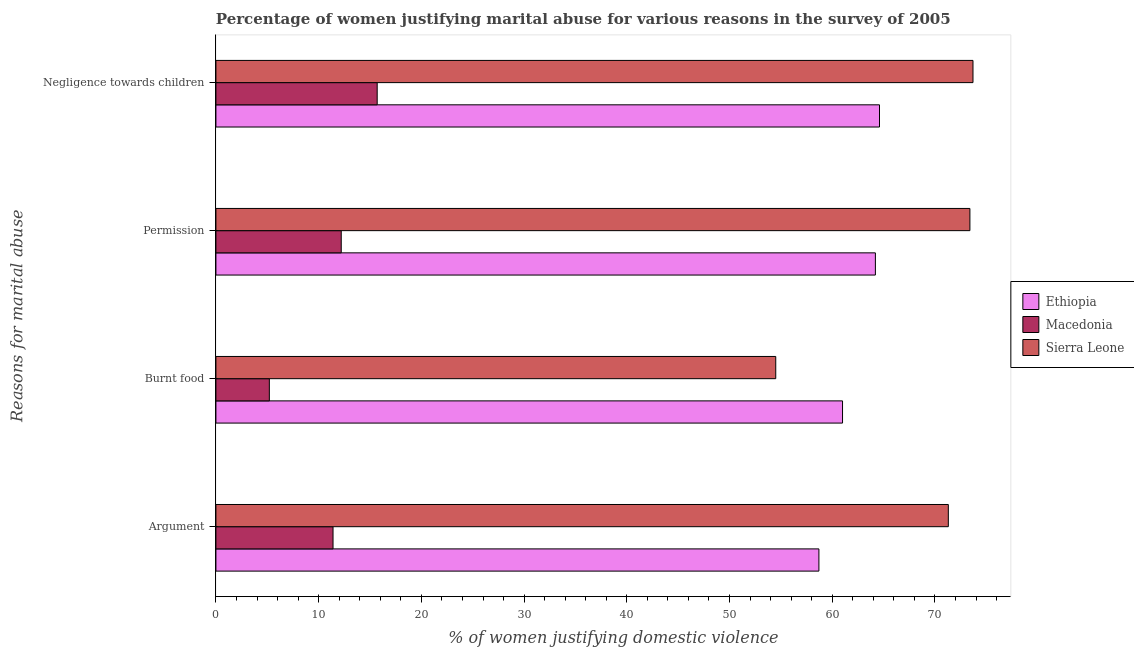How many different coloured bars are there?
Keep it short and to the point. 3. How many groups of bars are there?
Offer a very short reply. 4. Are the number of bars per tick equal to the number of legend labels?
Give a very brief answer. Yes. How many bars are there on the 4th tick from the bottom?
Provide a succinct answer. 3. What is the label of the 3rd group of bars from the top?
Your response must be concise. Burnt food. What is the percentage of women justifying abuse for showing negligence towards children in Sierra Leone?
Make the answer very short. 73.7. Across all countries, what is the maximum percentage of women justifying abuse for going without permission?
Offer a very short reply. 73.4. In which country was the percentage of women justifying abuse for going without permission maximum?
Keep it short and to the point. Sierra Leone. In which country was the percentage of women justifying abuse for going without permission minimum?
Offer a terse response. Macedonia. What is the total percentage of women justifying abuse for going without permission in the graph?
Provide a short and direct response. 149.8. What is the difference between the percentage of women justifying abuse in the case of an argument in Sierra Leone and that in Ethiopia?
Your response must be concise. 12.6. What is the difference between the percentage of women justifying abuse in the case of an argument in Macedonia and the percentage of women justifying abuse for going without permission in Ethiopia?
Your response must be concise. -52.8. What is the average percentage of women justifying abuse for going without permission per country?
Keep it short and to the point. 49.93. What is the difference between the percentage of women justifying abuse for showing negligence towards children and percentage of women justifying abuse for going without permission in Sierra Leone?
Your answer should be very brief. 0.3. What is the ratio of the percentage of women justifying abuse for showing negligence towards children in Macedonia to that in Ethiopia?
Your answer should be very brief. 0.24. Is the percentage of women justifying abuse for showing negligence towards children in Sierra Leone less than that in Macedonia?
Offer a terse response. No. Is the difference between the percentage of women justifying abuse for going without permission in Ethiopia and Macedonia greater than the difference between the percentage of women justifying abuse in the case of an argument in Ethiopia and Macedonia?
Keep it short and to the point. Yes. What is the difference between the highest and the second highest percentage of women justifying abuse in the case of an argument?
Ensure brevity in your answer.  12.6. What is the difference between the highest and the lowest percentage of women justifying abuse for showing negligence towards children?
Your answer should be compact. 58. Is the sum of the percentage of women justifying abuse for going without permission in Ethiopia and Macedonia greater than the maximum percentage of women justifying abuse in the case of an argument across all countries?
Your answer should be very brief. Yes. What does the 3rd bar from the top in Burnt food represents?
Give a very brief answer. Ethiopia. What does the 1st bar from the bottom in Argument represents?
Your answer should be very brief. Ethiopia. Is it the case that in every country, the sum of the percentage of women justifying abuse in the case of an argument and percentage of women justifying abuse for burning food is greater than the percentage of women justifying abuse for going without permission?
Offer a very short reply. Yes. Does the graph contain any zero values?
Provide a short and direct response. No. How many legend labels are there?
Provide a succinct answer. 3. How are the legend labels stacked?
Make the answer very short. Vertical. What is the title of the graph?
Your answer should be compact. Percentage of women justifying marital abuse for various reasons in the survey of 2005. What is the label or title of the X-axis?
Ensure brevity in your answer.  % of women justifying domestic violence. What is the label or title of the Y-axis?
Your response must be concise. Reasons for marital abuse. What is the % of women justifying domestic violence in Ethiopia in Argument?
Your answer should be compact. 58.7. What is the % of women justifying domestic violence in Macedonia in Argument?
Keep it short and to the point. 11.4. What is the % of women justifying domestic violence of Sierra Leone in Argument?
Your answer should be very brief. 71.3. What is the % of women justifying domestic violence of Sierra Leone in Burnt food?
Ensure brevity in your answer.  54.5. What is the % of women justifying domestic violence in Ethiopia in Permission?
Your answer should be very brief. 64.2. What is the % of women justifying domestic violence of Sierra Leone in Permission?
Your answer should be very brief. 73.4. What is the % of women justifying domestic violence in Ethiopia in Negligence towards children?
Ensure brevity in your answer.  64.6. What is the % of women justifying domestic violence of Sierra Leone in Negligence towards children?
Ensure brevity in your answer.  73.7. Across all Reasons for marital abuse, what is the maximum % of women justifying domestic violence of Ethiopia?
Give a very brief answer. 64.6. Across all Reasons for marital abuse, what is the maximum % of women justifying domestic violence of Macedonia?
Offer a very short reply. 15.7. Across all Reasons for marital abuse, what is the maximum % of women justifying domestic violence of Sierra Leone?
Make the answer very short. 73.7. Across all Reasons for marital abuse, what is the minimum % of women justifying domestic violence in Ethiopia?
Make the answer very short. 58.7. Across all Reasons for marital abuse, what is the minimum % of women justifying domestic violence of Sierra Leone?
Your answer should be compact. 54.5. What is the total % of women justifying domestic violence of Ethiopia in the graph?
Keep it short and to the point. 248.5. What is the total % of women justifying domestic violence in Macedonia in the graph?
Make the answer very short. 44.5. What is the total % of women justifying domestic violence of Sierra Leone in the graph?
Your answer should be very brief. 272.9. What is the difference between the % of women justifying domestic violence of Macedonia in Argument and that in Burnt food?
Offer a terse response. 6.2. What is the difference between the % of women justifying domestic violence in Sierra Leone in Argument and that in Negligence towards children?
Make the answer very short. -2.4. What is the difference between the % of women justifying domestic violence in Ethiopia in Burnt food and that in Permission?
Offer a very short reply. -3.2. What is the difference between the % of women justifying domestic violence of Macedonia in Burnt food and that in Permission?
Provide a succinct answer. -7. What is the difference between the % of women justifying domestic violence in Sierra Leone in Burnt food and that in Permission?
Ensure brevity in your answer.  -18.9. What is the difference between the % of women justifying domestic violence in Ethiopia in Burnt food and that in Negligence towards children?
Offer a terse response. -3.6. What is the difference between the % of women justifying domestic violence in Sierra Leone in Burnt food and that in Negligence towards children?
Offer a terse response. -19.2. What is the difference between the % of women justifying domestic violence of Ethiopia in Argument and the % of women justifying domestic violence of Macedonia in Burnt food?
Provide a succinct answer. 53.5. What is the difference between the % of women justifying domestic violence in Ethiopia in Argument and the % of women justifying domestic violence in Sierra Leone in Burnt food?
Ensure brevity in your answer.  4.2. What is the difference between the % of women justifying domestic violence of Macedonia in Argument and the % of women justifying domestic violence of Sierra Leone in Burnt food?
Ensure brevity in your answer.  -43.1. What is the difference between the % of women justifying domestic violence in Ethiopia in Argument and the % of women justifying domestic violence in Macedonia in Permission?
Provide a short and direct response. 46.5. What is the difference between the % of women justifying domestic violence of Ethiopia in Argument and the % of women justifying domestic violence of Sierra Leone in Permission?
Offer a terse response. -14.7. What is the difference between the % of women justifying domestic violence in Macedonia in Argument and the % of women justifying domestic violence in Sierra Leone in Permission?
Your answer should be very brief. -62. What is the difference between the % of women justifying domestic violence of Ethiopia in Argument and the % of women justifying domestic violence of Sierra Leone in Negligence towards children?
Make the answer very short. -15. What is the difference between the % of women justifying domestic violence in Macedonia in Argument and the % of women justifying domestic violence in Sierra Leone in Negligence towards children?
Your response must be concise. -62.3. What is the difference between the % of women justifying domestic violence of Ethiopia in Burnt food and the % of women justifying domestic violence of Macedonia in Permission?
Offer a terse response. 48.8. What is the difference between the % of women justifying domestic violence of Ethiopia in Burnt food and the % of women justifying domestic violence of Sierra Leone in Permission?
Offer a very short reply. -12.4. What is the difference between the % of women justifying domestic violence of Macedonia in Burnt food and the % of women justifying domestic violence of Sierra Leone in Permission?
Your answer should be very brief. -68.2. What is the difference between the % of women justifying domestic violence of Ethiopia in Burnt food and the % of women justifying domestic violence of Macedonia in Negligence towards children?
Your response must be concise. 45.3. What is the difference between the % of women justifying domestic violence of Ethiopia in Burnt food and the % of women justifying domestic violence of Sierra Leone in Negligence towards children?
Your response must be concise. -12.7. What is the difference between the % of women justifying domestic violence in Macedonia in Burnt food and the % of women justifying domestic violence in Sierra Leone in Negligence towards children?
Provide a succinct answer. -68.5. What is the difference between the % of women justifying domestic violence in Ethiopia in Permission and the % of women justifying domestic violence in Macedonia in Negligence towards children?
Your response must be concise. 48.5. What is the difference between the % of women justifying domestic violence in Macedonia in Permission and the % of women justifying domestic violence in Sierra Leone in Negligence towards children?
Provide a succinct answer. -61.5. What is the average % of women justifying domestic violence of Ethiopia per Reasons for marital abuse?
Your answer should be very brief. 62.12. What is the average % of women justifying domestic violence of Macedonia per Reasons for marital abuse?
Make the answer very short. 11.12. What is the average % of women justifying domestic violence of Sierra Leone per Reasons for marital abuse?
Provide a succinct answer. 68.22. What is the difference between the % of women justifying domestic violence of Ethiopia and % of women justifying domestic violence of Macedonia in Argument?
Offer a very short reply. 47.3. What is the difference between the % of women justifying domestic violence of Ethiopia and % of women justifying domestic violence of Sierra Leone in Argument?
Keep it short and to the point. -12.6. What is the difference between the % of women justifying domestic violence in Macedonia and % of women justifying domestic violence in Sierra Leone in Argument?
Your answer should be very brief. -59.9. What is the difference between the % of women justifying domestic violence of Ethiopia and % of women justifying domestic violence of Macedonia in Burnt food?
Your answer should be very brief. 55.8. What is the difference between the % of women justifying domestic violence in Ethiopia and % of women justifying domestic violence in Sierra Leone in Burnt food?
Provide a short and direct response. 6.5. What is the difference between the % of women justifying domestic violence in Macedonia and % of women justifying domestic violence in Sierra Leone in Burnt food?
Offer a terse response. -49.3. What is the difference between the % of women justifying domestic violence in Ethiopia and % of women justifying domestic violence in Sierra Leone in Permission?
Your answer should be very brief. -9.2. What is the difference between the % of women justifying domestic violence in Macedonia and % of women justifying domestic violence in Sierra Leone in Permission?
Your answer should be very brief. -61.2. What is the difference between the % of women justifying domestic violence in Ethiopia and % of women justifying domestic violence in Macedonia in Negligence towards children?
Give a very brief answer. 48.9. What is the difference between the % of women justifying domestic violence in Macedonia and % of women justifying domestic violence in Sierra Leone in Negligence towards children?
Your answer should be very brief. -58. What is the ratio of the % of women justifying domestic violence of Ethiopia in Argument to that in Burnt food?
Provide a short and direct response. 0.96. What is the ratio of the % of women justifying domestic violence in Macedonia in Argument to that in Burnt food?
Make the answer very short. 2.19. What is the ratio of the % of women justifying domestic violence of Sierra Leone in Argument to that in Burnt food?
Your answer should be compact. 1.31. What is the ratio of the % of women justifying domestic violence in Ethiopia in Argument to that in Permission?
Your response must be concise. 0.91. What is the ratio of the % of women justifying domestic violence in Macedonia in Argument to that in Permission?
Make the answer very short. 0.93. What is the ratio of the % of women justifying domestic violence in Sierra Leone in Argument to that in Permission?
Keep it short and to the point. 0.97. What is the ratio of the % of women justifying domestic violence of Ethiopia in Argument to that in Negligence towards children?
Make the answer very short. 0.91. What is the ratio of the % of women justifying domestic violence of Macedonia in Argument to that in Negligence towards children?
Your answer should be compact. 0.73. What is the ratio of the % of women justifying domestic violence of Sierra Leone in Argument to that in Negligence towards children?
Provide a short and direct response. 0.97. What is the ratio of the % of women justifying domestic violence of Ethiopia in Burnt food to that in Permission?
Make the answer very short. 0.95. What is the ratio of the % of women justifying domestic violence of Macedonia in Burnt food to that in Permission?
Your answer should be compact. 0.43. What is the ratio of the % of women justifying domestic violence in Sierra Leone in Burnt food to that in Permission?
Your answer should be compact. 0.74. What is the ratio of the % of women justifying domestic violence of Ethiopia in Burnt food to that in Negligence towards children?
Make the answer very short. 0.94. What is the ratio of the % of women justifying domestic violence of Macedonia in Burnt food to that in Negligence towards children?
Offer a terse response. 0.33. What is the ratio of the % of women justifying domestic violence in Sierra Leone in Burnt food to that in Negligence towards children?
Offer a very short reply. 0.74. What is the ratio of the % of women justifying domestic violence of Ethiopia in Permission to that in Negligence towards children?
Your response must be concise. 0.99. What is the ratio of the % of women justifying domestic violence of Macedonia in Permission to that in Negligence towards children?
Provide a short and direct response. 0.78. What is the difference between the highest and the second highest % of women justifying domestic violence in Sierra Leone?
Your answer should be compact. 0.3. What is the difference between the highest and the lowest % of women justifying domestic violence in Macedonia?
Provide a succinct answer. 10.5. 